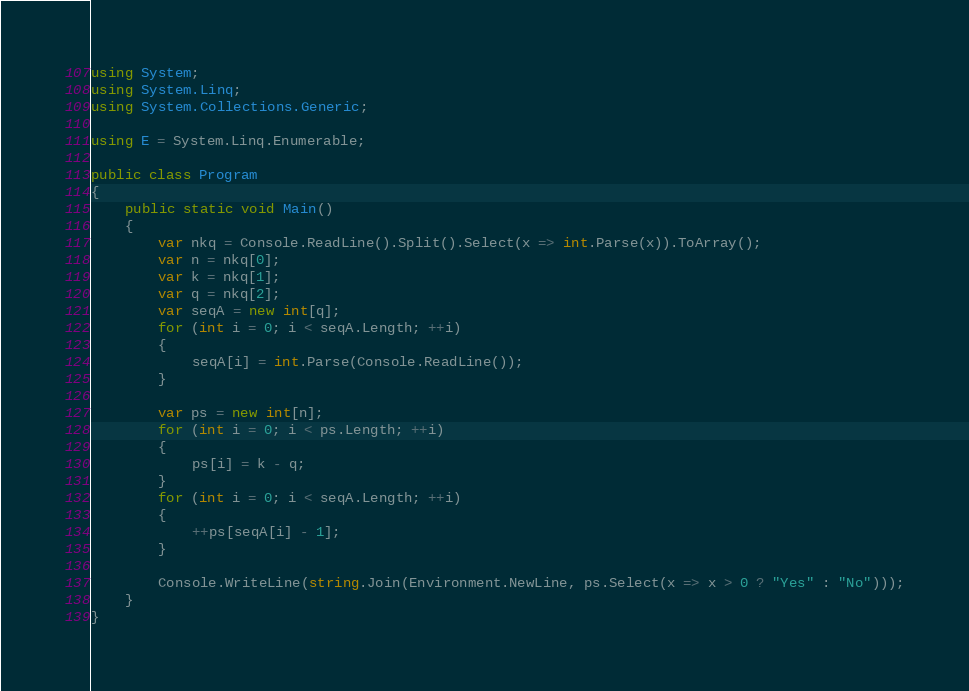<code> <loc_0><loc_0><loc_500><loc_500><_C#_>using System;
using System.Linq;
using System.Collections.Generic;

using E = System.Linq.Enumerable;

public class Program
{
    public static void Main()
    {
        var nkq = Console.ReadLine().Split().Select(x => int.Parse(x)).ToArray();
        var n = nkq[0];
        var k = nkq[1];
        var q = nkq[2];
        var seqA = new int[q];
        for (int i = 0; i < seqA.Length; ++i)
        {
            seqA[i] = int.Parse(Console.ReadLine());
        }

        var ps = new int[n];
        for (int i = 0; i < ps.Length; ++i)
        {
            ps[i] = k - q;
        }
        for (int i = 0; i < seqA.Length; ++i)
        {
            ++ps[seqA[i] - 1];
        }

        Console.WriteLine(string.Join(Environment.NewLine, ps.Select(x => x > 0 ? "Yes" : "No")));
    }
}
</code> 